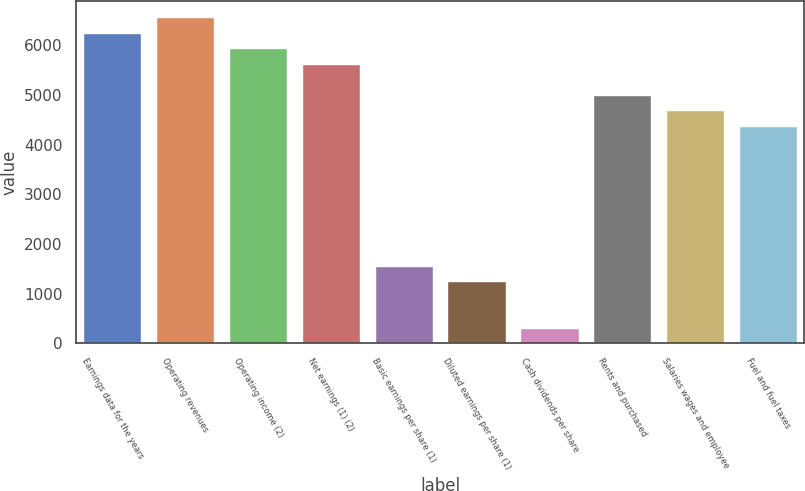Convert chart to OTSL. <chart><loc_0><loc_0><loc_500><loc_500><bar_chart><fcel>Earnings data for the years<fcel>Operating revenues<fcel>Operating income (2)<fcel>Net earnings (1) (2)<fcel>Basic earnings per share (1)<fcel>Diluted earnings per share (1)<fcel>Cash dividends per share<fcel>Rents and purchased<fcel>Salaries wages and employee<fcel>Fuel and fuel taxes<nl><fcel>6255.8<fcel>6568.58<fcel>5943.02<fcel>5630.24<fcel>1564.1<fcel>1251.32<fcel>312.98<fcel>5004.68<fcel>4691.9<fcel>4379.12<nl></chart> 